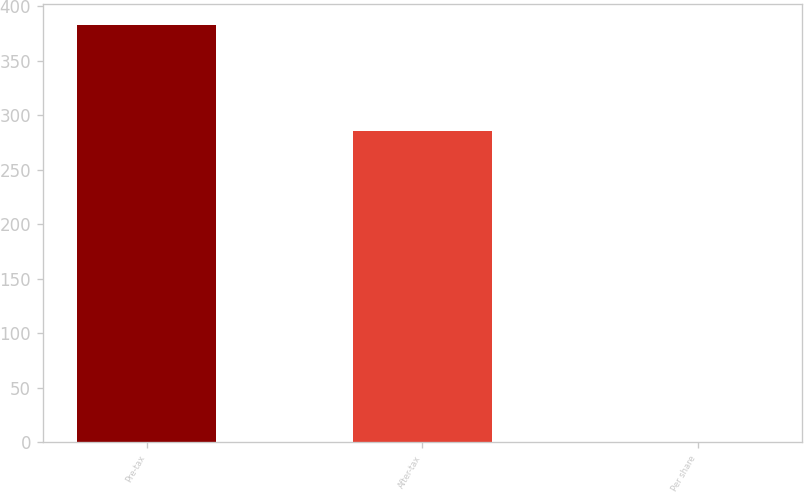Convert chart. <chart><loc_0><loc_0><loc_500><loc_500><bar_chart><fcel>Pre-tax<fcel>After-tax<fcel>Per share<nl><fcel>383<fcel>286<fcel>0.18<nl></chart> 